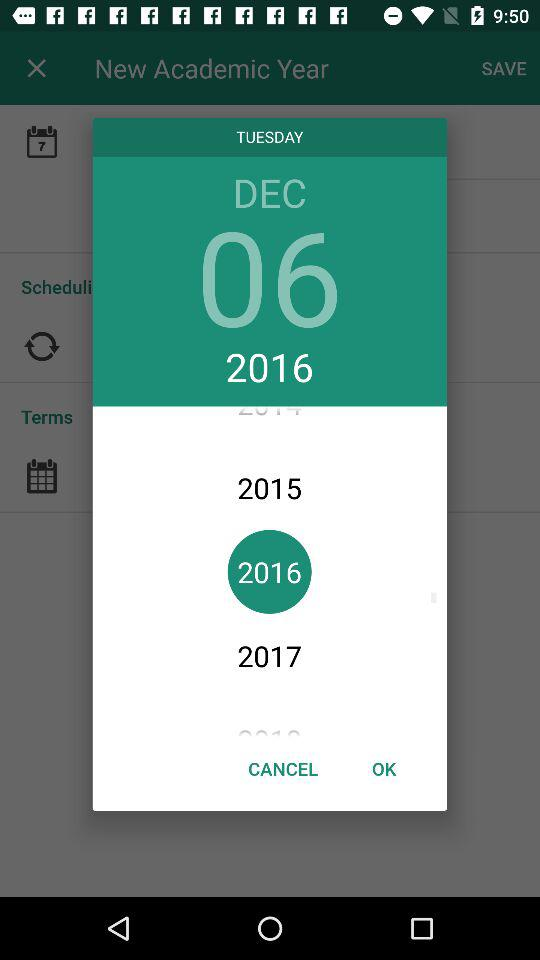What is the selected year? The selected year is 2016. 